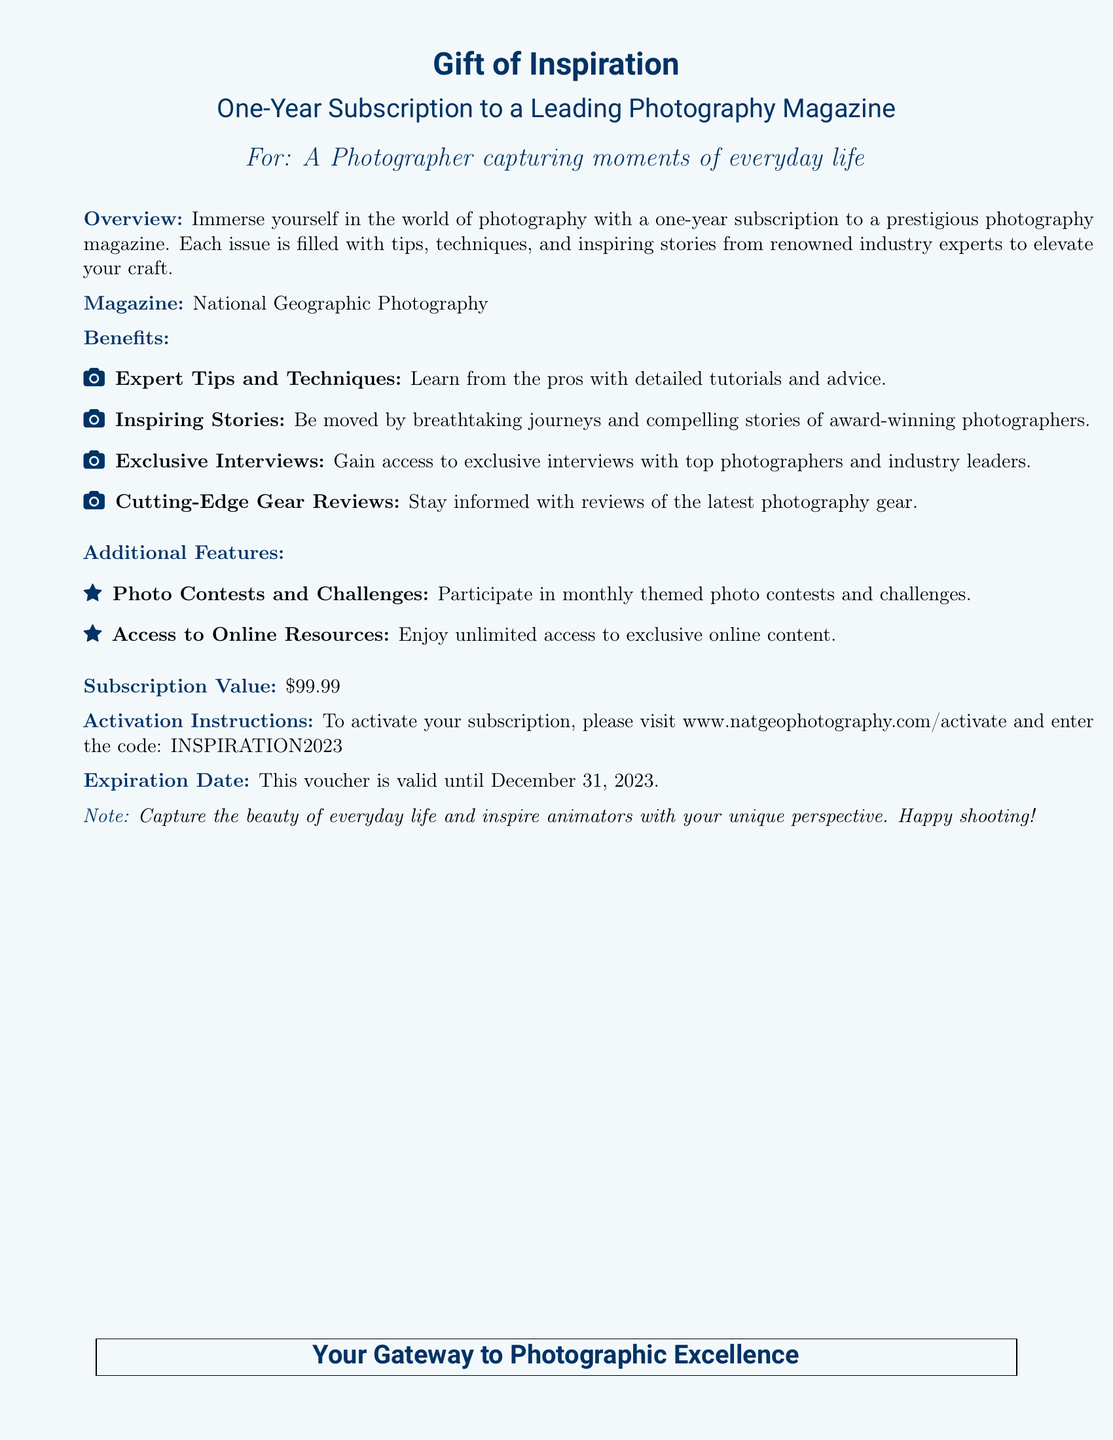What is the title of the gift voucher? The title is noted at the top of the document, describing the voucher purpose.
Answer: Gift of Inspiration What is the duration of the subscription? The duration is specified in the overview section of the document.
Answer: One-Year What is the value of the subscription? The subscription value is listed explicitly in the document.
Answer: $99.99 What is the name of the photography magazine? The magazine is mentioned under the magazine section of the document.
Answer: National Geographic Photography When does this voucher expire? The expiration date is clearly stated in the document towards the end.
Answer: December 31, 2023 What kind of content is included in the magazine? The document lists several types of content found in the magazine.
Answer: Tips, techniques, and inspiring stories Where can you activate your subscription? The activation instructions provide a specific website for subscription activation.
Answer: www.natgeophotography.com/activate What do you gain access to with this subscription? Additional features of the subscription highlight what users can access.
Answer: Online resources What code is required to activate the subscription? The code is provided in the activation instructions section of the document.
Answer: INSPIRATION2023 